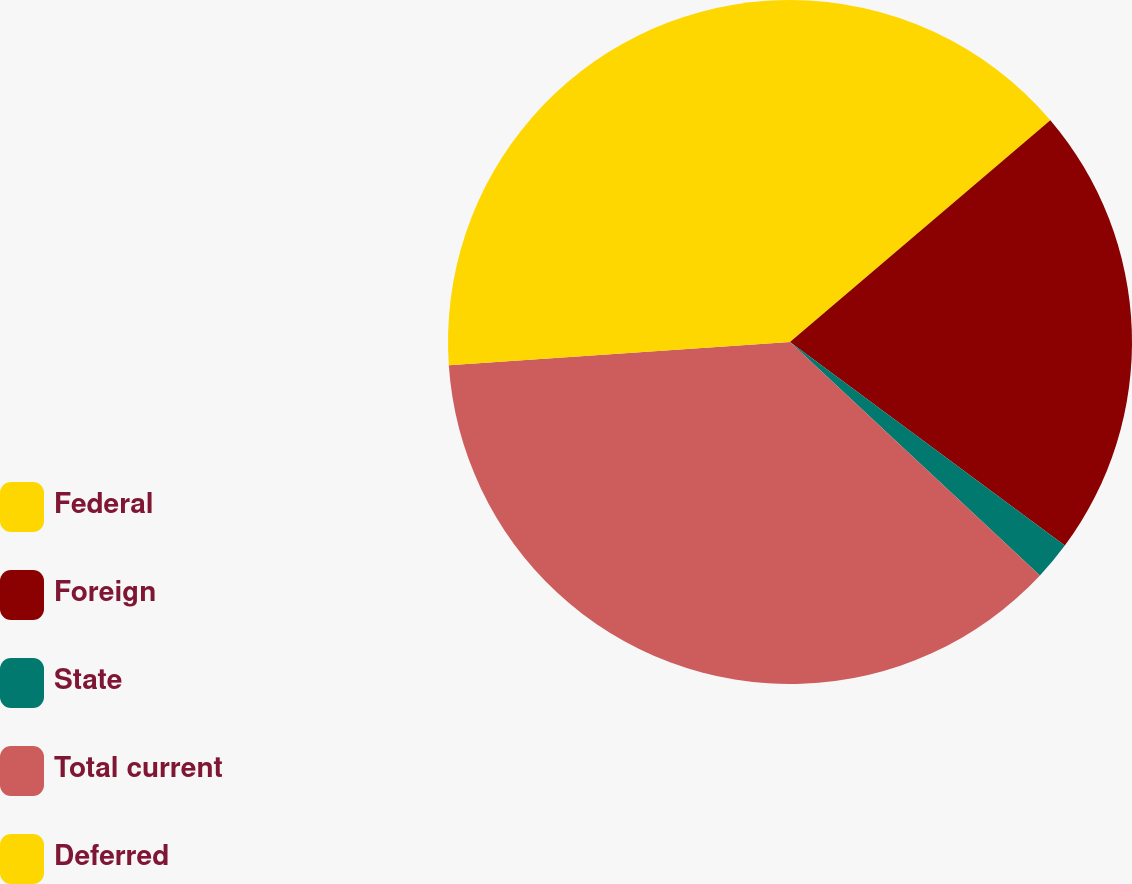Convert chart to OTSL. <chart><loc_0><loc_0><loc_500><loc_500><pie_chart><fcel>Federal<fcel>Foreign<fcel>State<fcel>Total current<fcel>Deferred<nl><fcel>13.77%<fcel>21.38%<fcel>1.81%<fcel>36.96%<fcel>26.09%<nl></chart> 